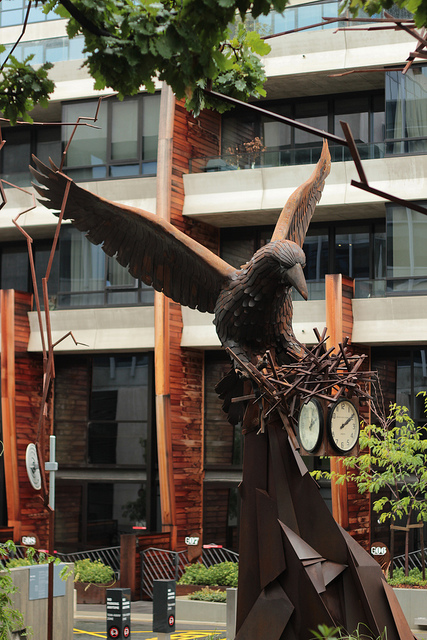Identify and read out the text in this image. 606 